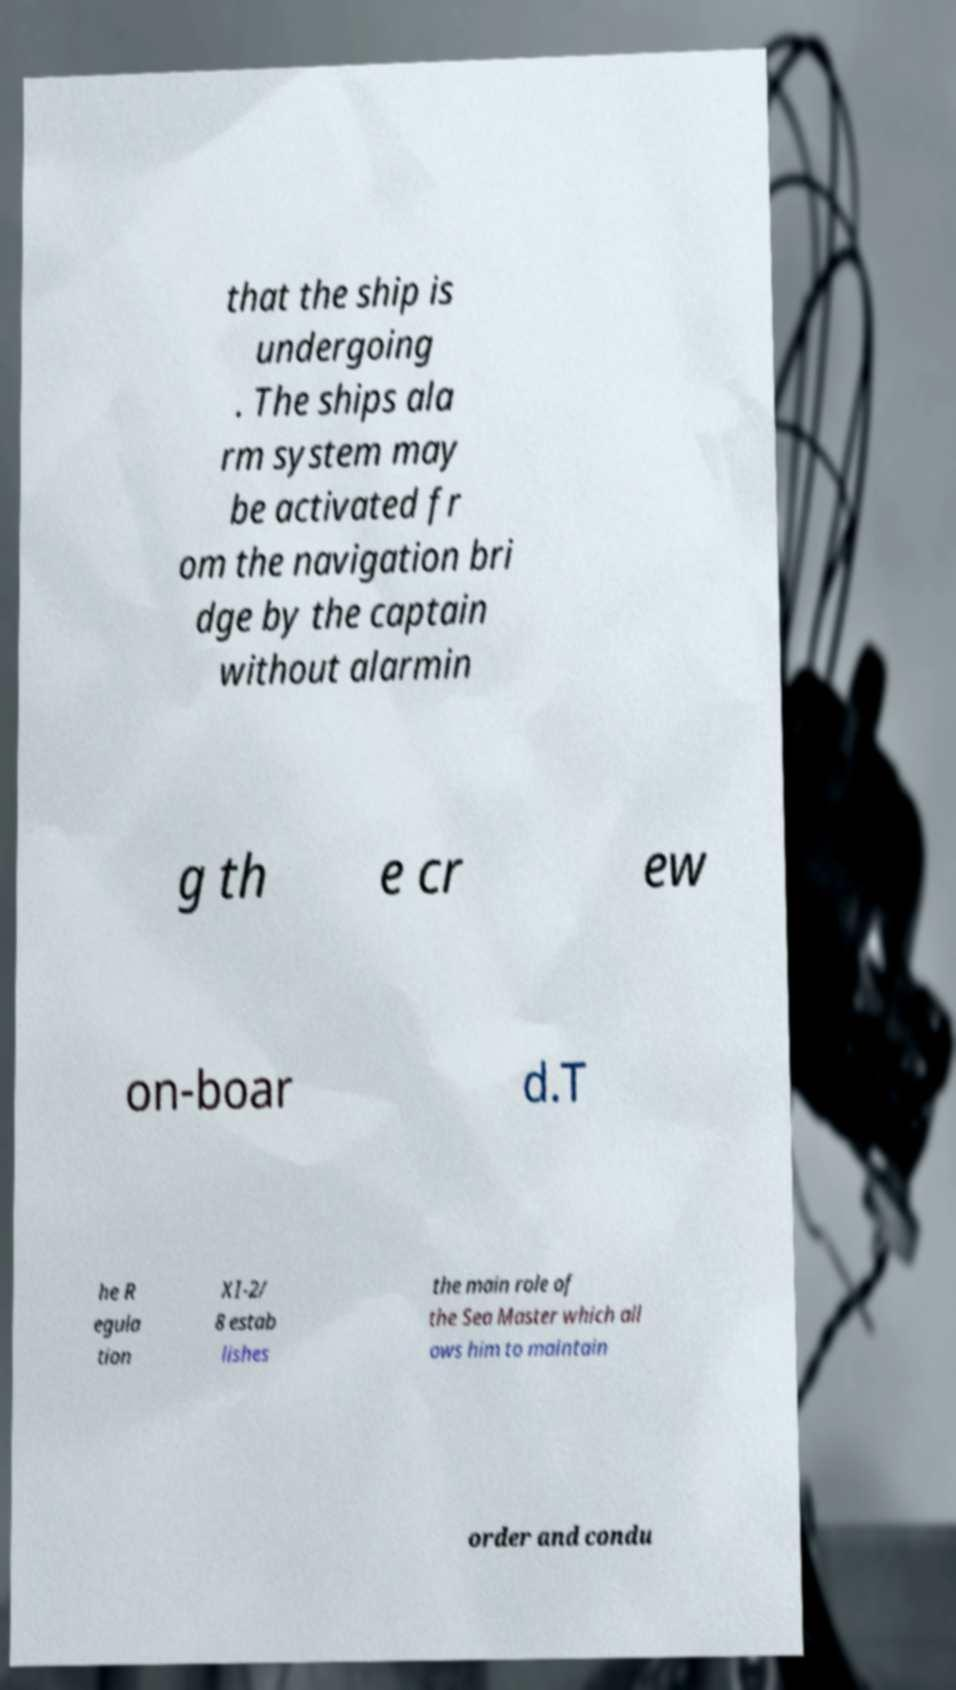Please identify and transcribe the text found in this image. that the ship is undergoing . The ships ala rm system may be activated fr om the navigation bri dge by the captain without alarmin g th e cr ew on-boar d.T he R egula tion XI-2/ 8 estab lishes the main role of the Sea Master which all ows him to maintain order and condu 